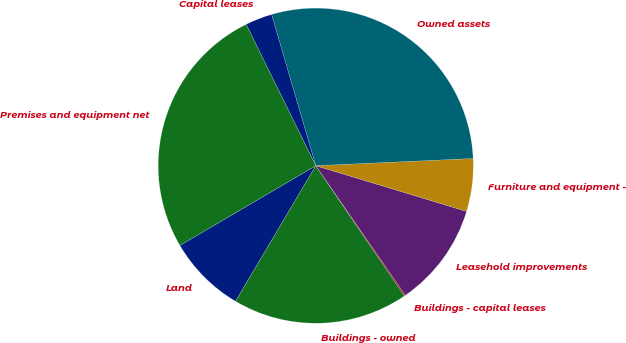Convert chart. <chart><loc_0><loc_0><loc_500><loc_500><pie_chart><fcel>Land<fcel>Buildings - owned<fcel>Buildings - capital leases<fcel>Leasehold improvements<fcel>Furniture and equipment -<fcel>Owned assets<fcel>Capital leases<fcel>Premises and equipment net<nl><fcel>8.05%<fcel>18.01%<fcel>0.12%<fcel>10.69%<fcel>5.41%<fcel>28.8%<fcel>2.76%<fcel>26.16%<nl></chart> 